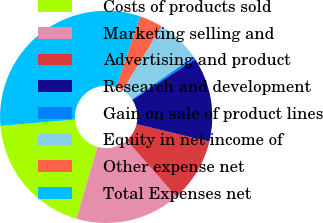<chart> <loc_0><loc_0><loc_500><loc_500><pie_chart><fcel>Costs of products sold<fcel>Marketing selling and<fcel>Advertising and product<fcel>Research and development<fcel>Gain on sale of product lines<fcel>Equity in net income of<fcel>Other expense net<fcel>Total Expenses net<nl><fcel>19.12%<fcel>16.0%<fcel>9.78%<fcel>12.89%<fcel>0.43%<fcel>6.66%<fcel>3.55%<fcel>31.57%<nl></chart> 